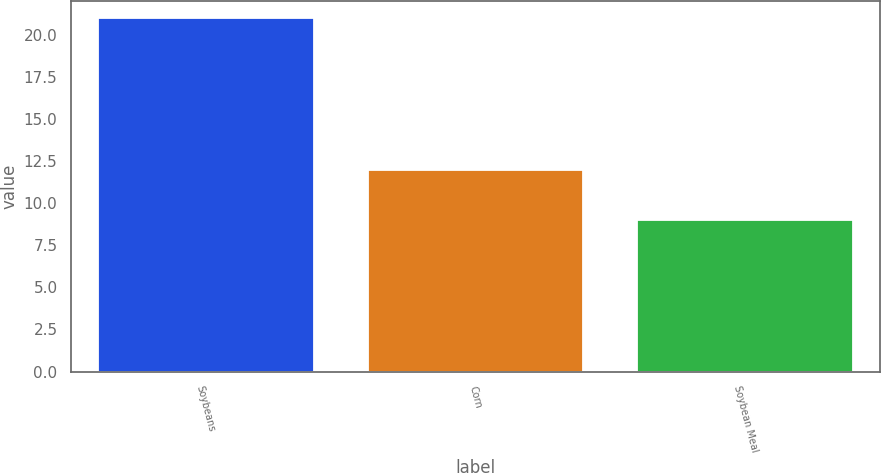Convert chart. <chart><loc_0><loc_0><loc_500><loc_500><bar_chart><fcel>Soybeans<fcel>Corn<fcel>Soybean Meal<nl><fcel>21<fcel>12<fcel>9<nl></chart> 